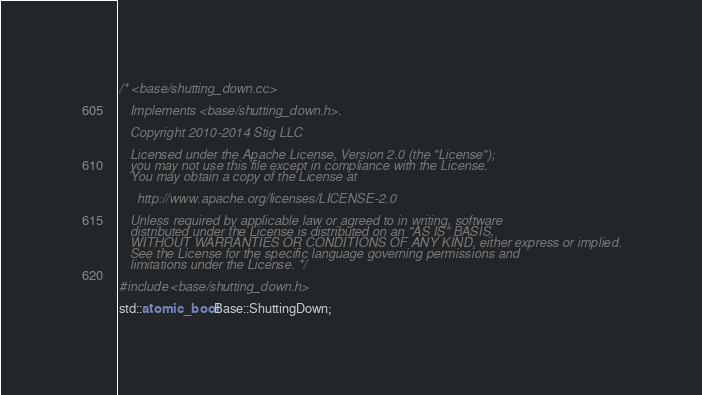<code> <loc_0><loc_0><loc_500><loc_500><_C++_>/* <base/shutting_down.cc>

   Implements <base/shutting_down.h>.

   Copyright 2010-2014 Stig LLC

   Licensed under the Apache License, Version 2.0 (the "License");
   you may not use this file except in compliance with the License.
   You may obtain a copy of the License at

     http://www.apache.org/licenses/LICENSE-2.0

   Unless required by applicable law or agreed to in writing, software
   distributed under the License is distributed on an "AS IS" BASIS,
   WITHOUT WARRANTIES OR CONDITIONS OF ANY KIND, either express or implied.
   See the License for the specific language governing permissions and
   limitations under the License. */

#include <base/shutting_down.h>

std::atomic_bool Base::ShuttingDown;
</code> 